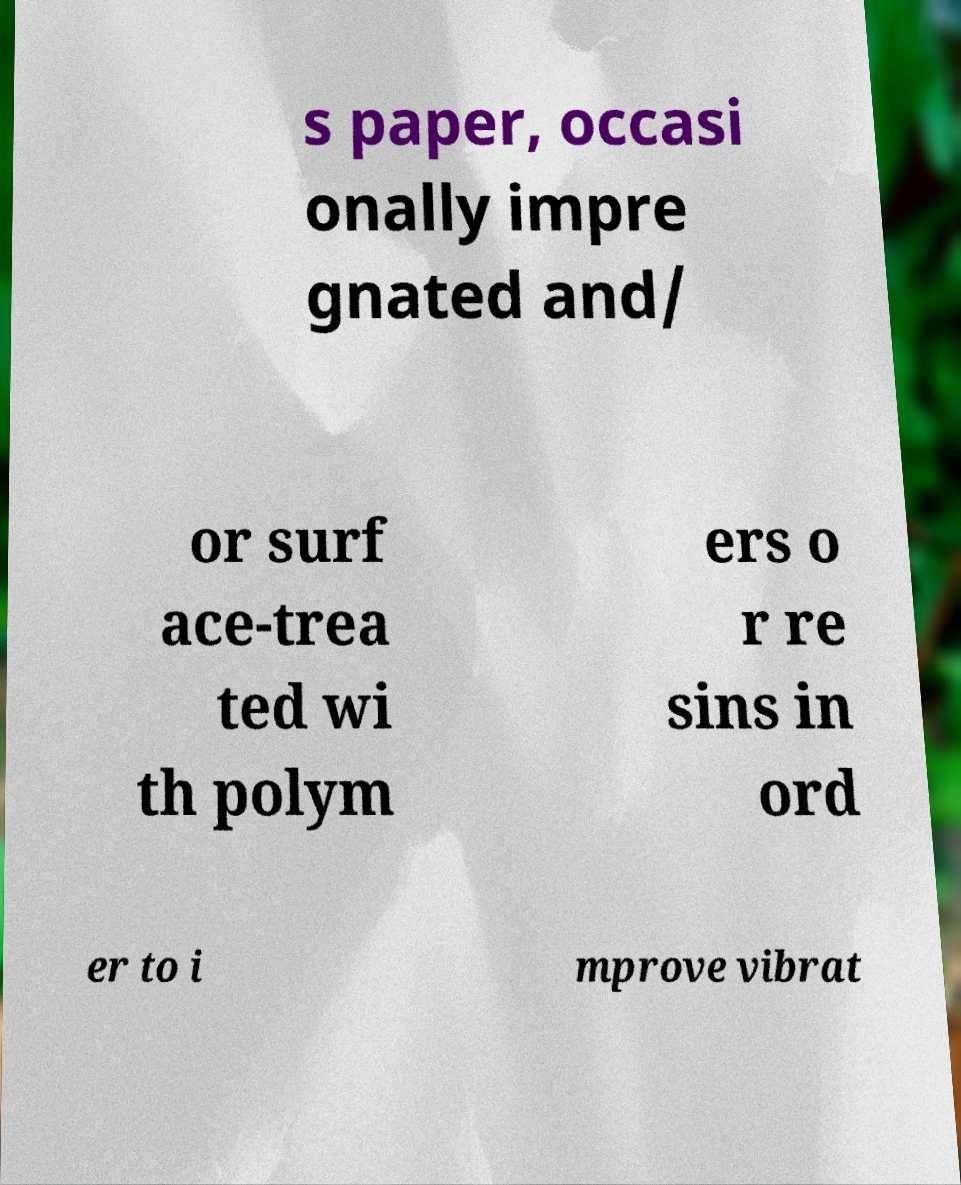Can you accurately transcribe the text from the provided image for me? s paper, occasi onally impre gnated and/ or surf ace-trea ted wi th polym ers o r re sins in ord er to i mprove vibrat 